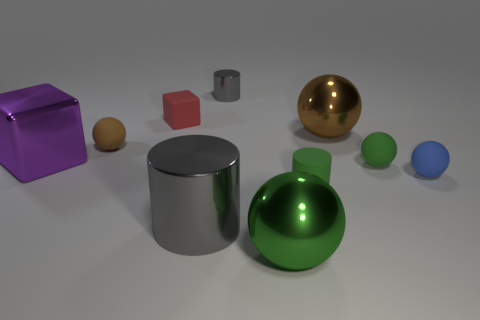Subtract all purple cylinders. Subtract all green cubes. How many cylinders are left? 3 Subtract all cylinders. How many objects are left? 7 Add 5 shiny objects. How many shiny objects are left? 10 Add 3 yellow shiny cylinders. How many yellow shiny cylinders exist? 3 Subtract 0 green cubes. How many objects are left? 10 Subtract all blue rubber spheres. Subtract all big gray shiny cylinders. How many objects are left? 8 